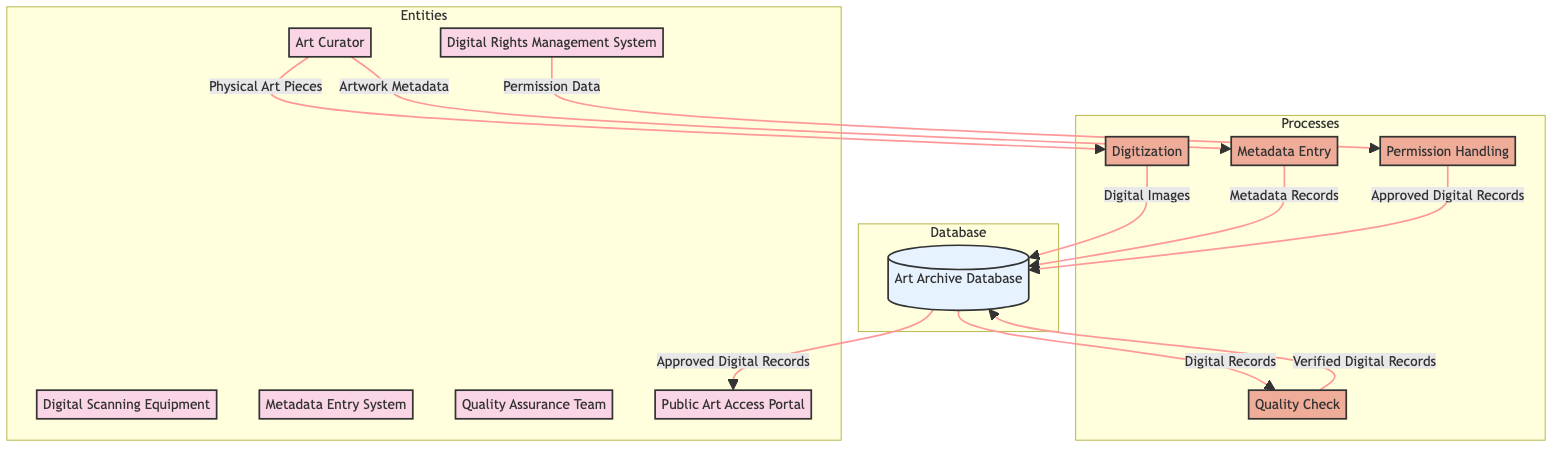What is the input for the Digitization process? The input for the Digitization process, as defined in the diagram, is "Physical Art Pieces". This is stated directly in the process description in the diagram.
Answer: Physical Art Pieces How many entities are present in the diagram? The diagram lists six distinct entities: Art Curator, Art Archive Database, Digital Scanning Equipment, Metadata Entry System, Quality Assurance Team, Digital Rights Management System, and Public Art Access Portal. Counting these gives a total of six entities.
Answer: Six What is the primary output of the Quality Check process? According to the diagram, the primary output of the Quality Check process is "Verified Digital Records". This is also clearly stated in the process description within the diagram.
Answer: Verified Digital Records Which entity is responsible for handling permission data? The Digital Rights Management System is the entity responsible for handling permission data, as shown in the diagram where it is directed to send Permission Data to the Permission Handling process.
Answer: Digital Rights Management System What are the final approved records available to the public? The final approved records available to the public, as indicated in the flow to the Public Art Access Portal, are "Approved Digital Records". This indicates the end-node's output in the diagram.
Answer: Approved Digital Records What process involves inputting detailed information about art pieces? The process that involves inputting detailed information about art pieces is the Metadata Entry process. This is evident from the diagram where artwork metadata is directed to this specific process.
Answer: Metadata Entry Which team is involved in ensuring the accuracy of digital records? The Quality Assurance Team is involved in ensuring the accuracy of digital records, as depicted in the flow diagram where it receives Digital Records and performs a quality check.
Answer: Quality Assurance Team How many processes are shown in the diagram? The diagram illustrates four distinct processes: Digitization, Metadata Entry, Quality Check, and Permission Handling. Counting these processes gives a total of four.
Answer: Four What is the relationship between the Art Curator and the Metadata Entry System? The relationship between the Art Curator and the Metadata Entry System is that the Art Curator provides "Artwork Metadata" to the Metadata Entry System, as indicated by the flow arrow in the diagram.
Answer: Artwork Metadata 